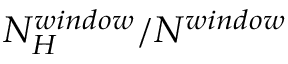Convert formula to latex. <formula><loc_0><loc_0><loc_500><loc_500>N _ { H } ^ { w i n d o w } / N ^ { w i n d o w }</formula> 